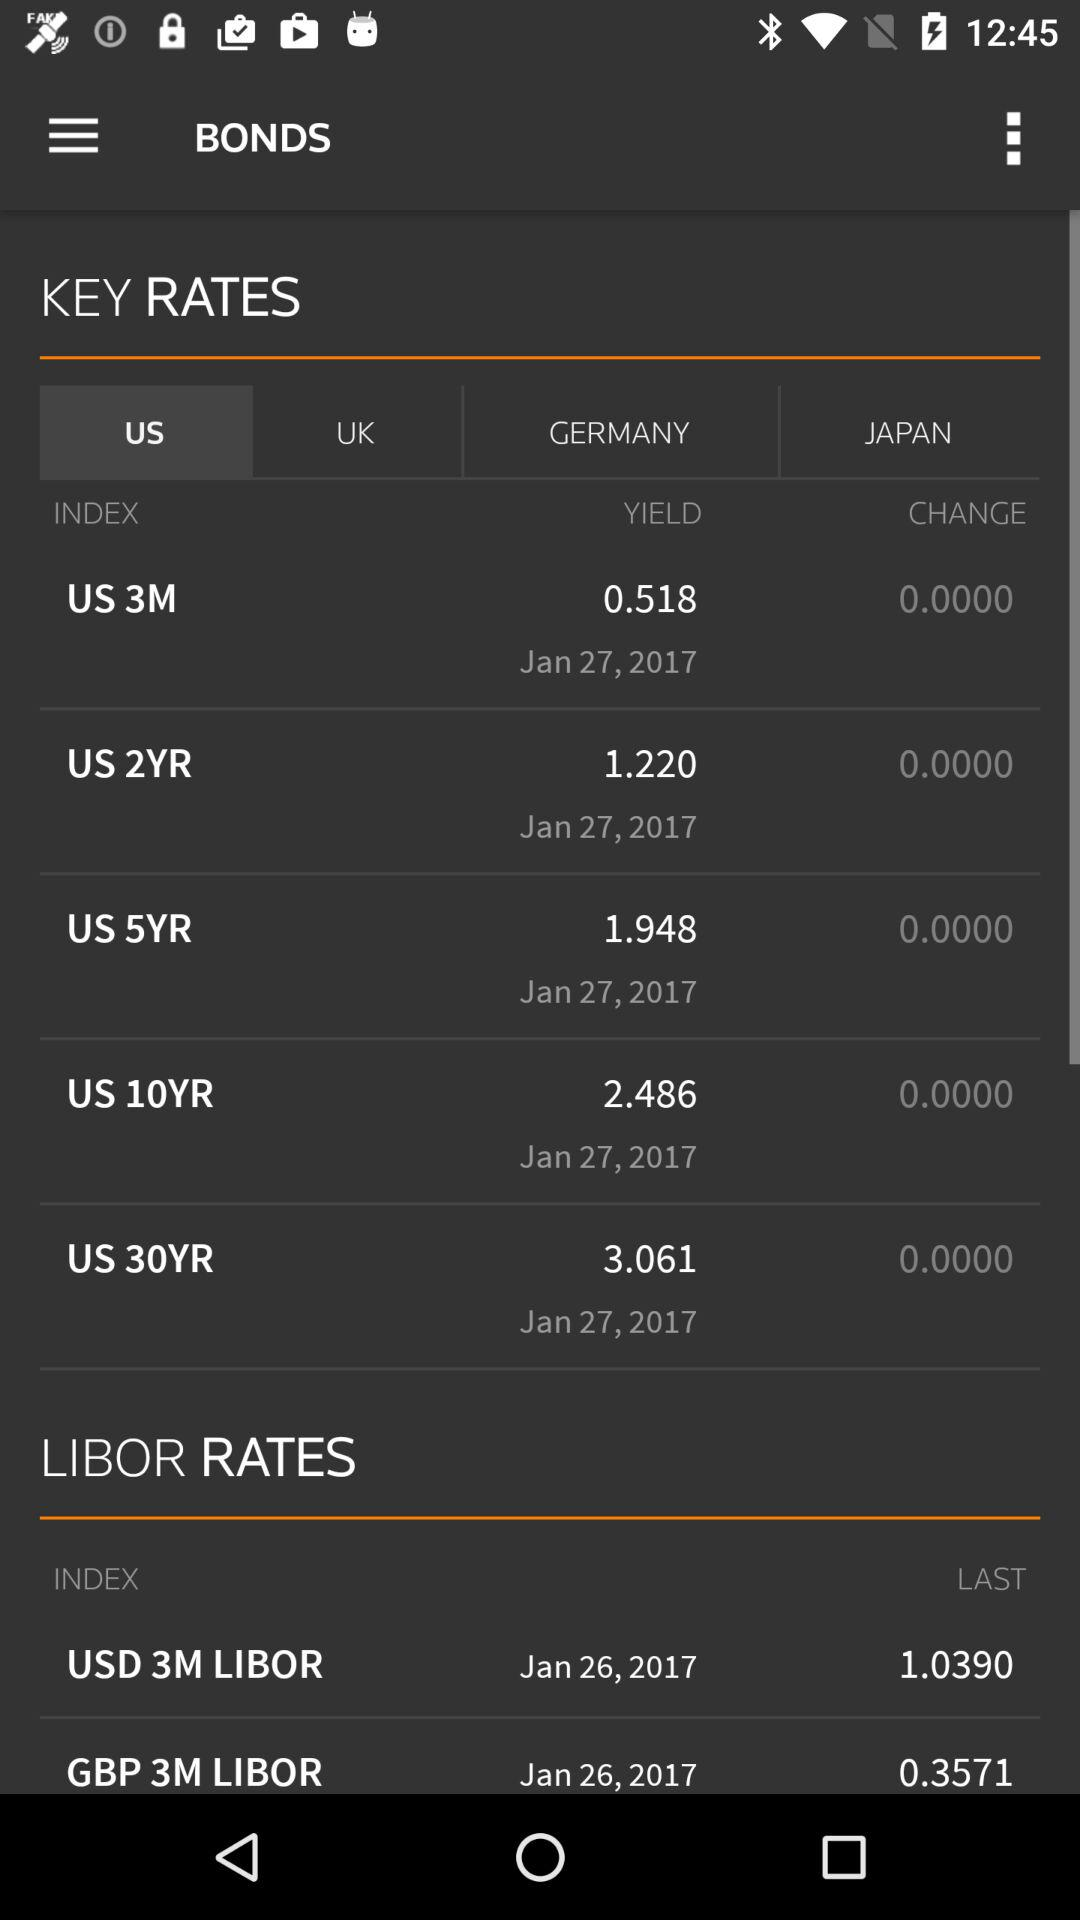What is the difference in yield between the US 3M and US 2YR bonds?
Answer the question using a single word or phrase. 0.702 